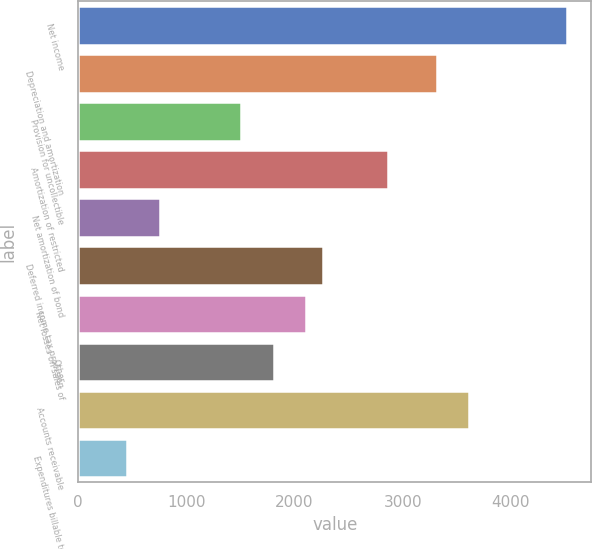Convert chart. <chart><loc_0><loc_0><loc_500><loc_500><bar_chart><fcel>Net income<fcel>Depreciation and amortization<fcel>Provision for uncollectible<fcel>Amortization of restricted<fcel>Net amortization of bond<fcel>Deferred income tax provision<fcel>Net losses on sales of<fcel>Other<fcel>Accounts receivable<fcel>Expenditures billable to<nl><fcel>4516.9<fcel>3312.58<fcel>1506.1<fcel>2860.96<fcel>753.4<fcel>2258.8<fcel>2108.26<fcel>1807.18<fcel>3613.66<fcel>452.32<nl></chart> 